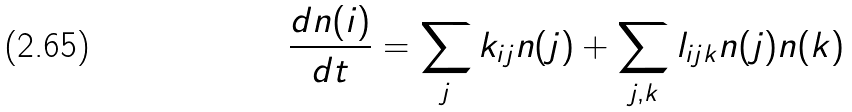Convert formula to latex. <formula><loc_0><loc_0><loc_500><loc_500>\frac { d n ( i ) } { d t } = \sum _ { j } k _ { i j } n ( j ) + \sum _ { j , k } l _ { i j k } n ( j ) n ( k )</formula> 